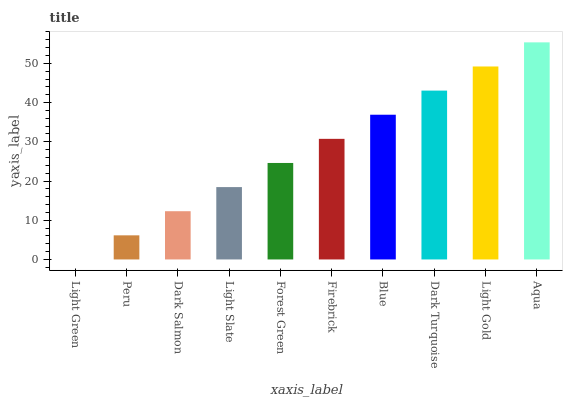Is Light Green the minimum?
Answer yes or no. Yes. Is Aqua the maximum?
Answer yes or no. Yes. Is Peru the minimum?
Answer yes or no. No. Is Peru the maximum?
Answer yes or no. No. Is Peru greater than Light Green?
Answer yes or no. Yes. Is Light Green less than Peru?
Answer yes or no. Yes. Is Light Green greater than Peru?
Answer yes or no. No. Is Peru less than Light Green?
Answer yes or no. No. Is Firebrick the high median?
Answer yes or no. Yes. Is Forest Green the low median?
Answer yes or no. Yes. Is Light Green the high median?
Answer yes or no. No. Is Light Green the low median?
Answer yes or no. No. 